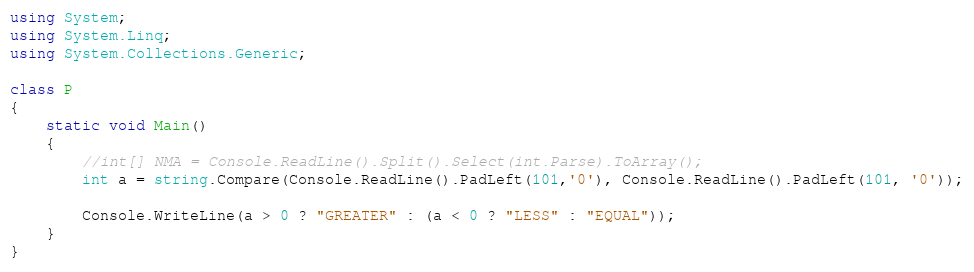Convert code to text. <code><loc_0><loc_0><loc_500><loc_500><_C#_>using System;
using System.Linq;
using System.Collections.Generic;

class P
{
    static void Main()
    {
        //int[] NMA = Console.ReadLine().Split().Select(int.Parse).ToArray();
        int a = string.Compare(Console.ReadLine().PadLeft(101,'0'), Console.ReadLine().PadLeft(101, '0'));
        
        Console.WriteLine(a > 0 ? "GREATER" : (a < 0 ? "LESS" : "EQUAL"));
    }
}</code> 